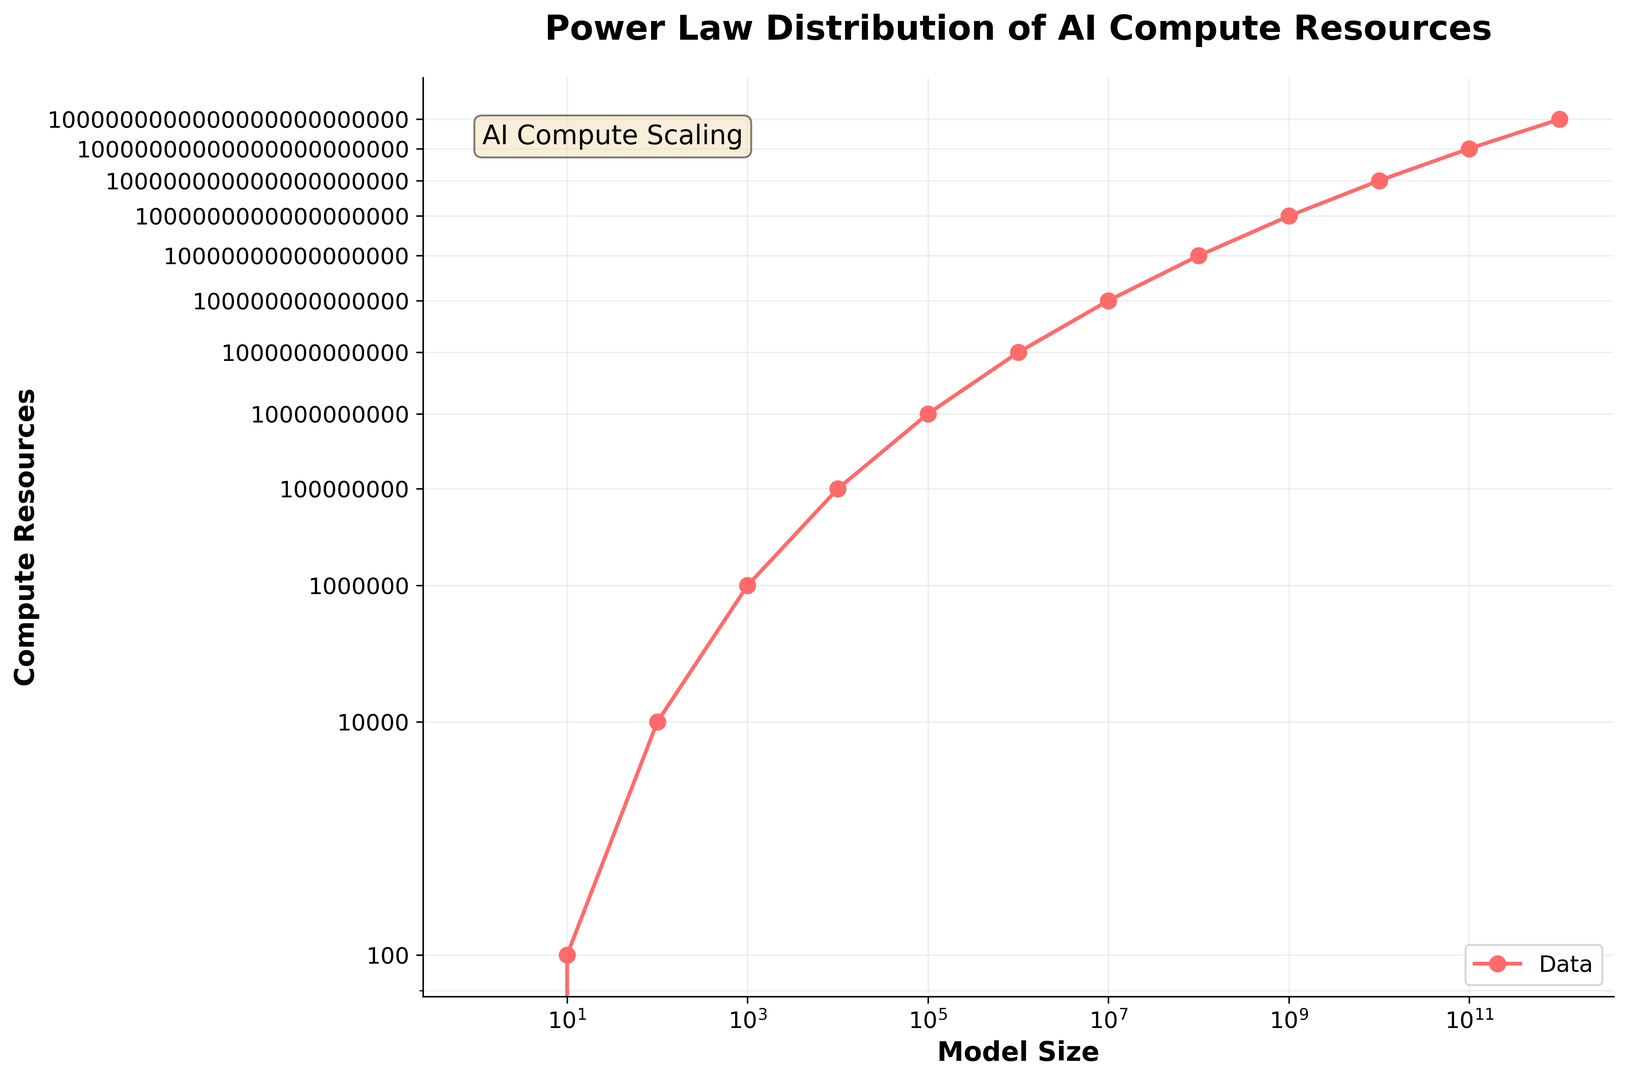What is the relationship between model size and compute resources in the figure? By observing the log-log plot, it's clear that the relationship between model size (x-axis) and compute resources (y-axis) follows a power law distribution. As the model size increases, the compute resources increase exponentially.
Answer: Power law distribution Which model size requires 1,000,000,000,000 compute resources? To determine the model size that matches 1,000,000,000,000 compute resources, find the corresponding data point on the log-log plot. The value is approximately around model size 1,000,000.
Answer: 1,000,000 How does the compute resource requirement change when the model size increases from 10 to 100? It's a comparison question. From the figure, increasing the model size from 10 to 100 changes the compute resources from 100 to 10,000. The increase is by a factor of 100.
Answer: 100 times increase If the trend continues, predict the compute resources needed for a model size of 1,000,000,000,000. The trend follows a power law distribution. By observing the pattern, compute resources needed exponentially grow. Given the model size 1,000,000,000,000, compute resources will be 1,000,000,000,000,000,000,000,000,000.
Answer: 1 octillion Compare the model sizes that require 100,000 and 1,000,000,000,000,000,000,000 compute resources. By referencing the data points and the plot, model sizes requiring 100,000 compute resources are around 1,000, and those needing 1,000,000,000,000,000,000,000 compute resources are around 10,000,000,000.
Answer: 1,000 and 10,000,000,000 What is the color used for the data points and the line in the plot? By viewing the plot, the color used for both data points and the connecting line is red.
Answer: Red What is the label of the x-axis? By observing the x-axis, the label is "Model Size".
Answer: Model Size At what location is the legend placed in the plot? The legend can be seen located at the lower right of the figure.
Answer: Lower right Which axes have grid lines enabled? By inspecting the plot, both the x-axis and y-axis have grid lines enabled.
Answer: Both axes 